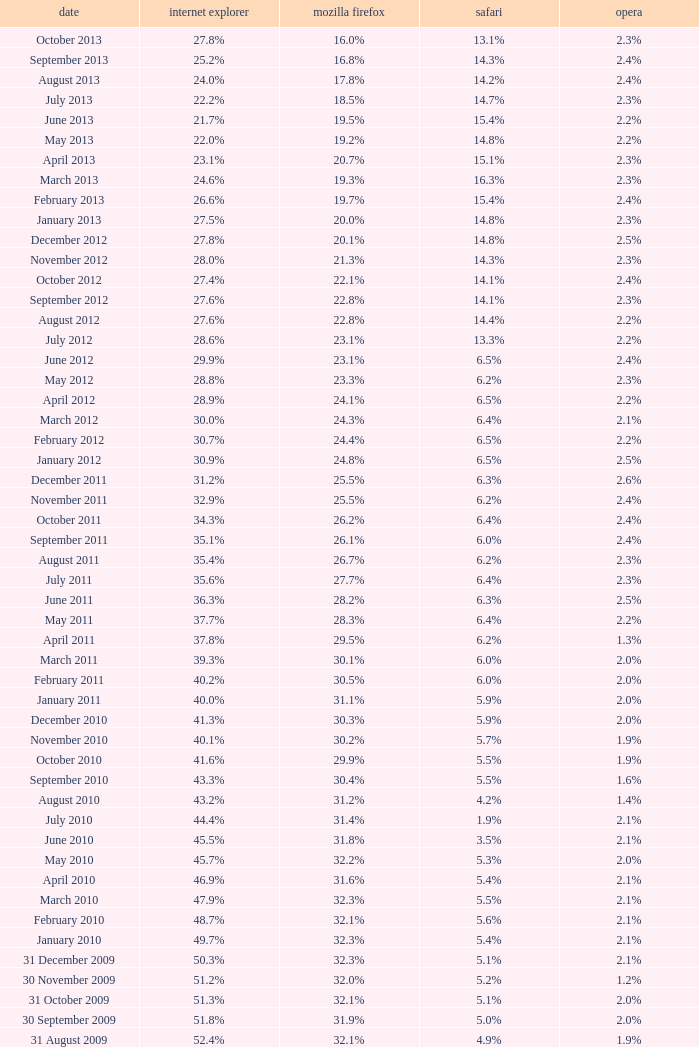What is the firefox value with a 1.8% opera on 30 July 2007? 25.1%. 